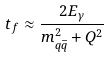<formula> <loc_0><loc_0><loc_500><loc_500>t _ { f } \approx \frac { 2 E _ { \gamma } } { m _ { q \bar { q } } ^ { 2 } + Q ^ { 2 } }</formula> 